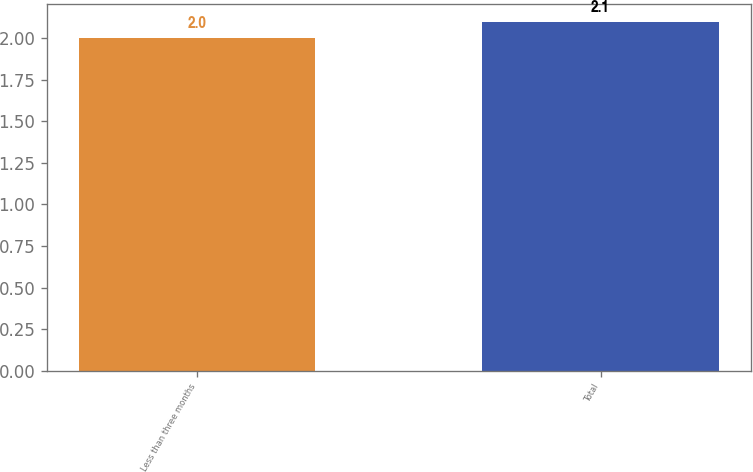<chart> <loc_0><loc_0><loc_500><loc_500><bar_chart><fcel>Less than three months<fcel>Total<nl><fcel>2<fcel>2.1<nl></chart> 